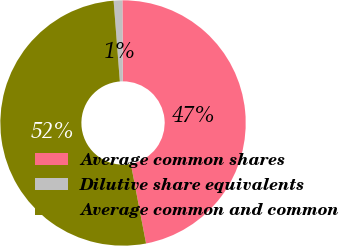<chart> <loc_0><loc_0><loc_500><loc_500><pie_chart><fcel>Average common shares<fcel>Dilutive share equivalents<fcel>Average common and common<nl><fcel>47.08%<fcel>1.14%<fcel>51.78%<nl></chart> 